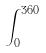Convert formula to latex. <formula><loc_0><loc_0><loc_500><loc_500>\int _ { 0 } ^ { 3 6 0 }</formula> 